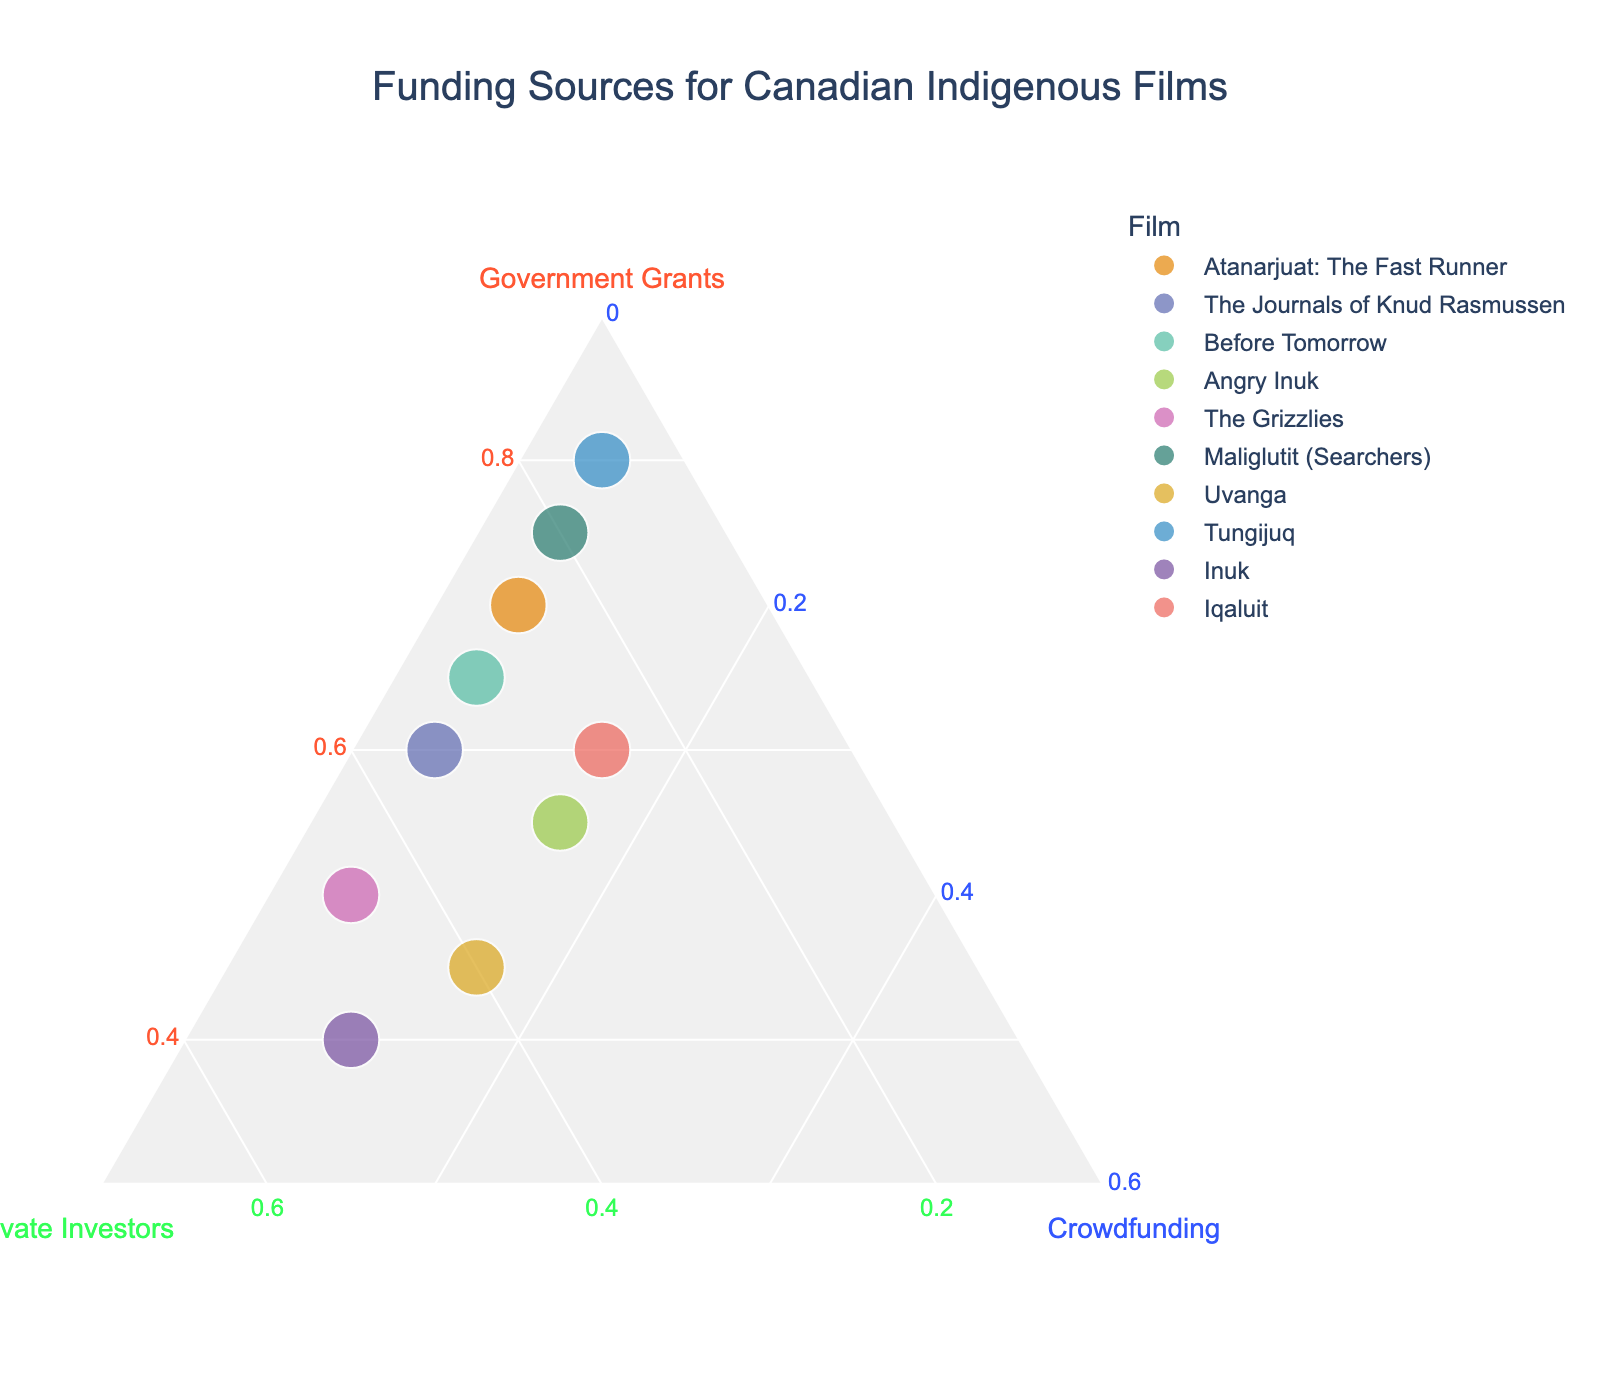What's the title of the figure? The title is located at the top of the figure.
Answer: Funding Sources for Canadian Indigenous Films How many films are represented in the chart? Count the number of points or data points in the chart. There are 10 points each representing a film.
Answer: 10 Which film received the highest percentage of government grants? Look for the data point closest to the "Government Grants" axis or vertex (a-axis). "Tungijuq" is closest to this axis with 80%.
Answer: Tungijuq Which film has equal contributions from private investors and crowdfunding? Find the data point where the contributions from private investors and crowdfunding are equal. "Uvanga" has both private investors and crowdfunding at 15%.
Answer: Uvanga What is the film with the lowest percentage of government grants? Find the data point furthest from the "Government Grants" axis. "Inuk" is furthest with 40%.
Answer: Inuk Between "Atanarjuat: The Fast Runner" and "The Journals of Knud Rasmussen," which one has a higher percentage of private investors? Compare the positions of the two data points relative to the "Private Investors" axis. The "Private Investors" percentage for "The Journals of Knud Rasmussen" is 35%, which is higher than "Atanarjuat: The Fast Runner" at 25%.
Answer: The Journals of Knud Rasmussen What is the average percentage of private investors across all films? Sum the percentages of private investors and divide by the number of films. The sum is 35+25+30+30+45+20+40+15+50+25 = 315, and the average is 315/10 = 31.5%.
Answer: 31.5% Which film has the highest crowdfunding percentage? Identify the data point closest to the "Crowdfunding" axis. "Iqaluit" is closest with 15%.
Answer: Angry Inuk Which film has the closest funding breakdown to "Before Tomorrow"? Find the data point closest to "Before Tomorrow" in the ternary plot. The closest point by visual inspection is "The Journals of Knud Rasmussen" with percentages (60, 35, 5) compared to "Before Tomorrow" with (65, 30, 5).
Answer: The Journals of Knud Rasmussen In terms of private investor funding, is "Maliglutit (Searchers)" above or below the average percentage for private investors? The average percentage for private investors is 31.5%. "Maliglutit (Searchers)" has 20%, which is below the average.
Answer: Below 